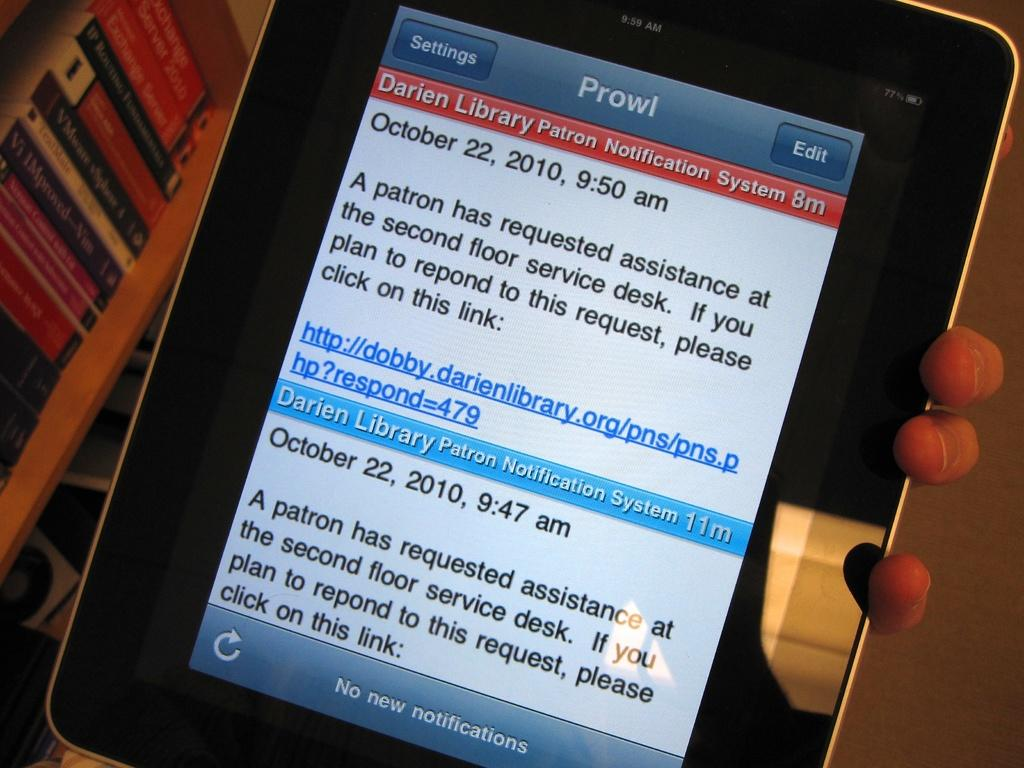What electronic device is visible in the image? There is a tablet in the image. What is located to the left of the tablet? There are books in a rack to the left of the tablet. What type of surface can be seen in the image? A floor is visible in the image. Who is holding the tablet in the image? A person is holding the tablet. What arithmetic problem is the person solving on the tablet? There is no indication in the image that the person is solving an arithmetic problem on the tablet. What degree does the person holding the tablet have? There is no information about the person's degree in the image. 